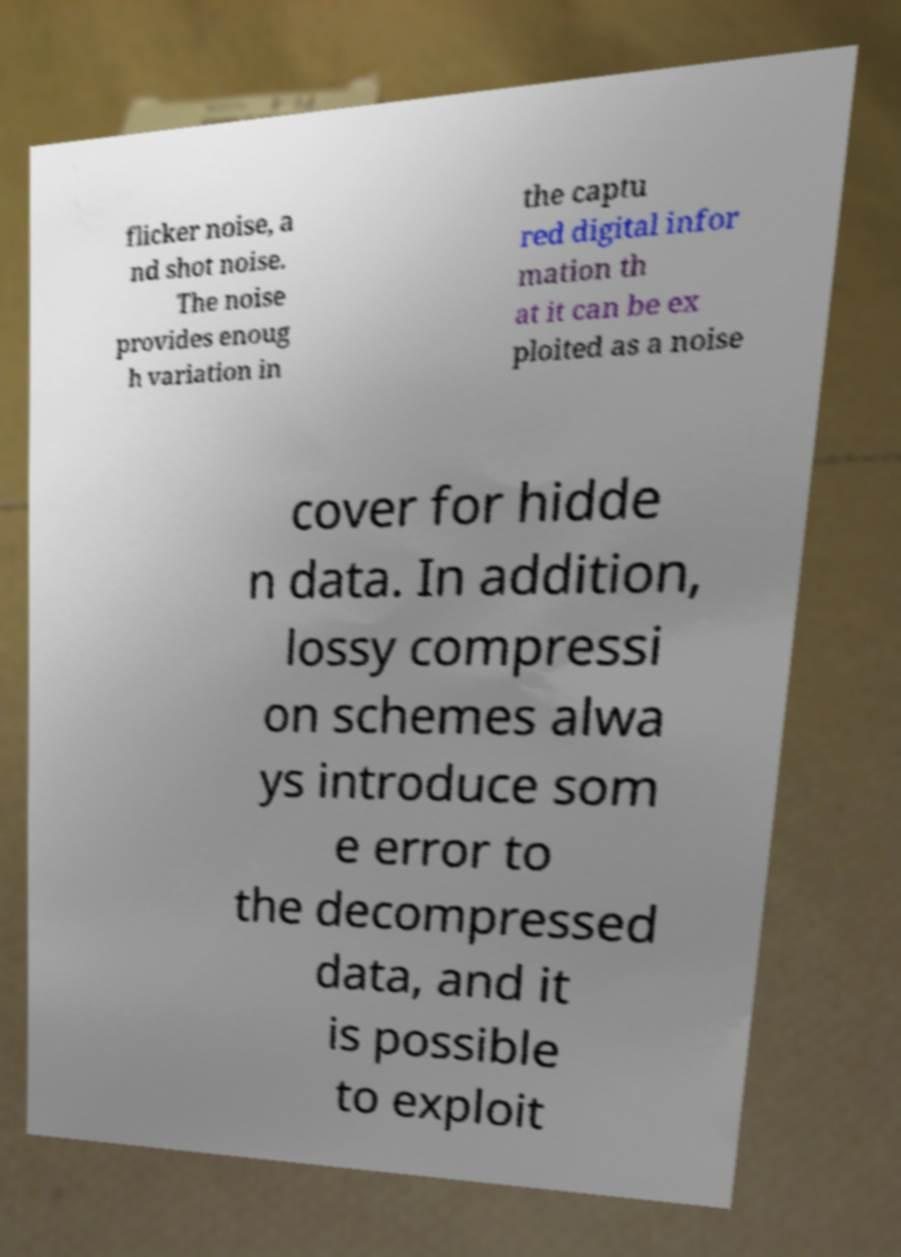There's text embedded in this image that I need extracted. Can you transcribe it verbatim? flicker noise, a nd shot noise. The noise provides enoug h variation in the captu red digital infor mation th at it can be ex ploited as a noise cover for hidde n data. In addition, lossy compressi on schemes alwa ys introduce som e error to the decompressed data, and it is possible to exploit 